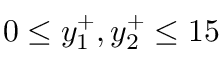<formula> <loc_0><loc_0><loc_500><loc_500>0 \leq y _ { 1 } ^ { + } , y _ { 2 } ^ { + } \leq 1 5</formula> 